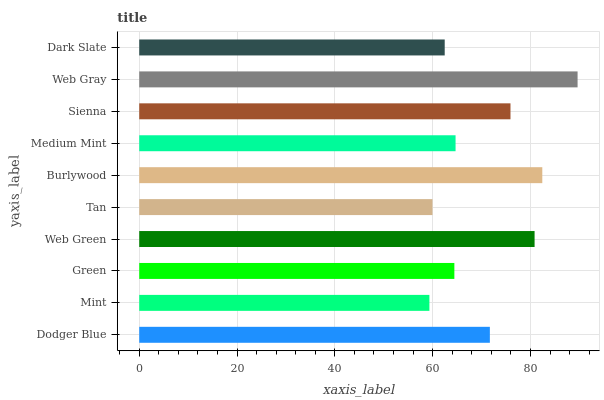Is Mint the minimum?
Answer yes or no. Yes. Is Web Gray the maximum?
Answer yes or no. Yes. Is Green the minimum?
Answer yes or no. No. Is Green the maximum?
Answer yes or no. No. Is Green greater than Mint?
Answer yes or no. Yes. Is Mint less than Green?
Answer yes or no. Yes. Is Mint greater than Green?
Answer yes or no. No. Is Green less than Mint?
Answer yes or no. No. Is Dodger Blue the high median?
Answer yes or no. Yes. Is Medium Mint the low median?
Answer yes or no. Yes. Is Web Gray the high median?
Answer yes or no. No. Is Green the low median?
Answer yes or no. No. 